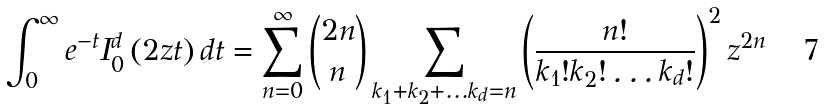<formula> <loc_0><loc_0><loc_500><loc_500>\int _ { 0 } ^ { \infty } e ^ { - t } I _ { 0 } ^ { d } \left ( 2 z t \right ) d t = \sum _ { n = 0 } ^ { \infty } { 2 n \choose n } \sum _ { k _ { 1 } + k _ { 2 } + \dots k _ { d } = n } \left ( \frac { n ! } { k _ { 1 } ! k _ { 2 } ! \dots k _ { d } ! } \right ) ^ { 2 } z ^ { 2 n }</formula> 